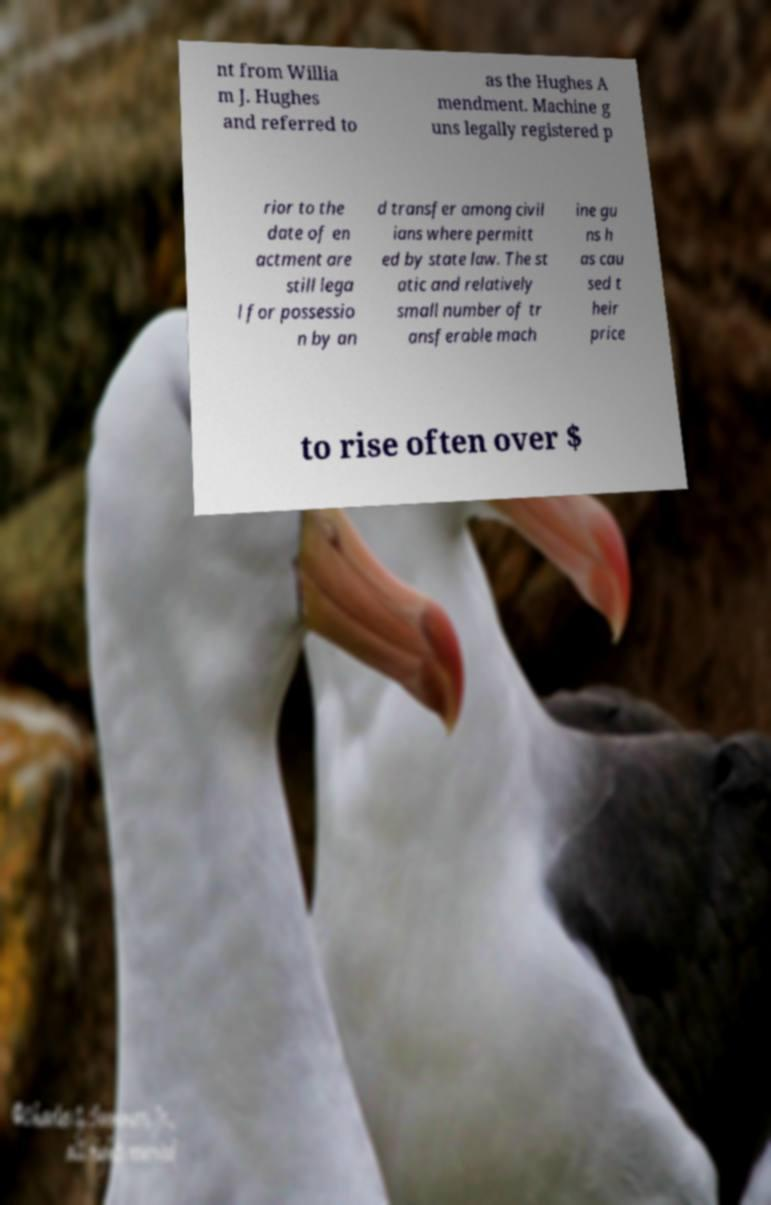Can you accurately transcribe the text from the provided image for me? nt from Willia m J. Hughes and referred to as the Hughes A mendment. Machine g uns legally registered p rior to the date of en actment are still lega l for possessio n by an d transfer among civil ians where permitt ed by state law. The st atic and relatively small number of tr ansferable mach ine gu ns h as cau sed t heir price to rise often over $ 